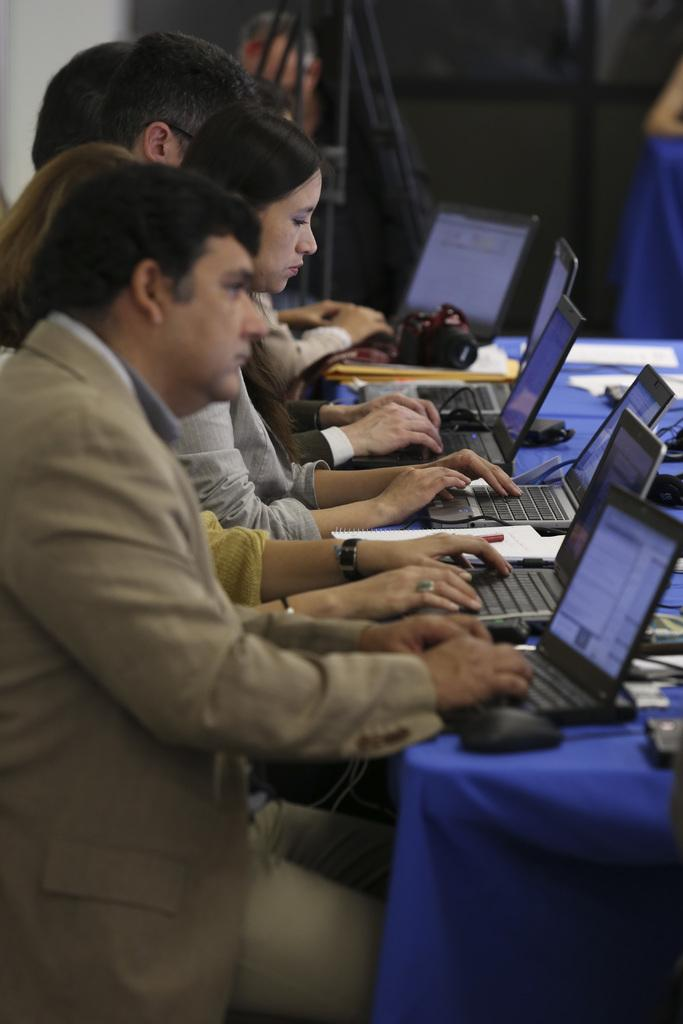How many people are sitting at the table in the image? There are many persons sitting at the table in the image. What electronic devices can be seen on the table? There are laptops and a camera on the table. What type of input device is present on the table? There are mouses on the table. What else is on the table besides electronic devices? There are papers on the table. What can be seen in the background of the image? There is a curtain and a wall in the background. What type of chalk is being used to draw on the wall in the image? There is no chalk or drawing on the wall in the image. How does the dock help the persons sitting at the table in the image? There is no dock present in the image; it is not related to the scene. 